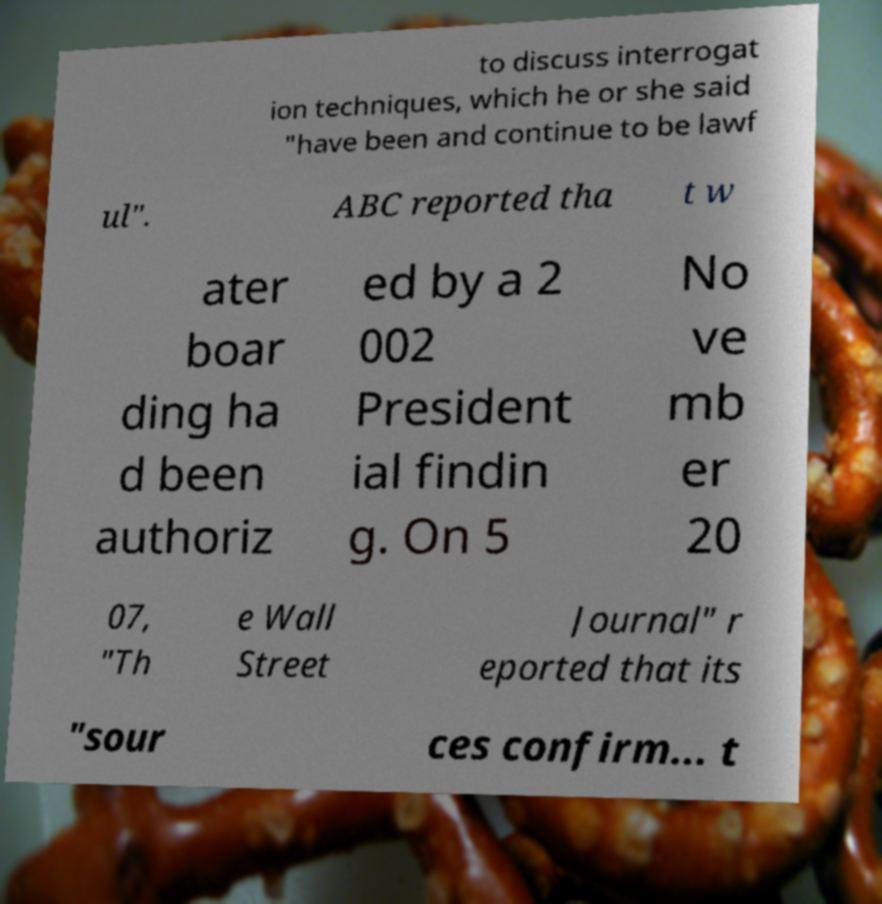Please identify and transcribe the text found in this image. to discuss interrogat ion techniques, which he or she said "have been and continue to be lawf ul". ABC reported tha t w ater boar ding ha d been authoriz ed by a 2 002 President ial findin g. On 5 No ve mb er 20 07, "Th e Wall Street Journal" r eported that its "sour ces confirm... t 